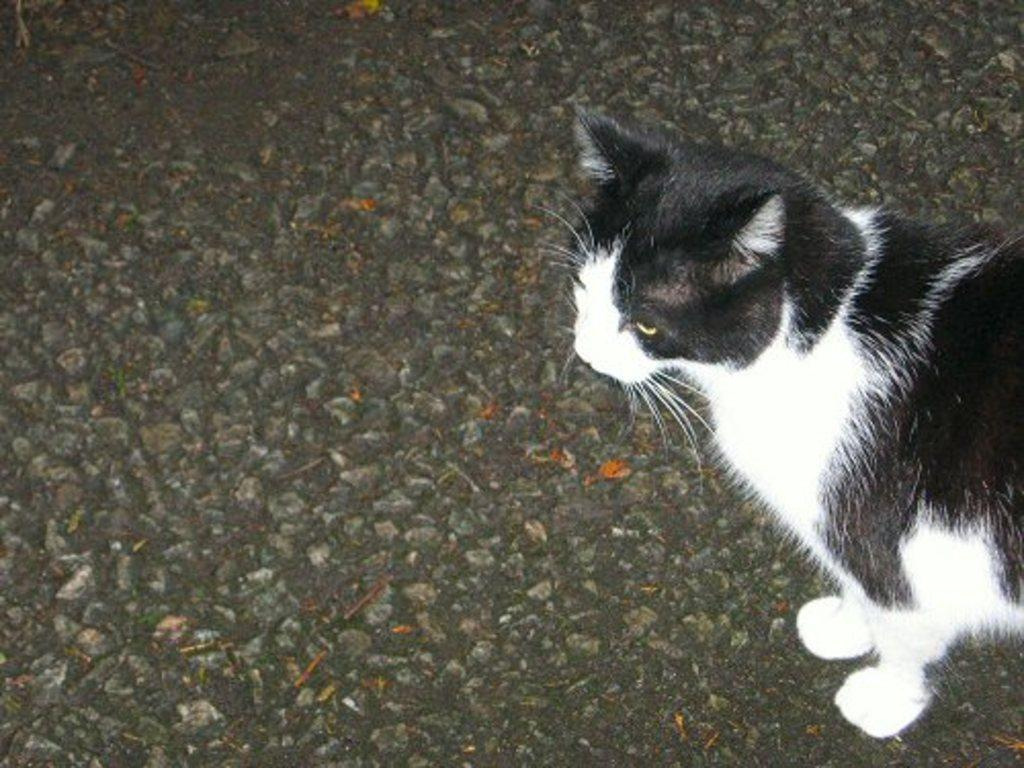What type of animal is in the image? There is a cat in the image. What colors can be seen on the cat? The cat is black and white in color. What is the cat standing on in the image? The cat is on a black surface. In which direction is the cat facing in the image? The provided facts do not mention the direction the cat is facing, so it cannot be determined from the image. 